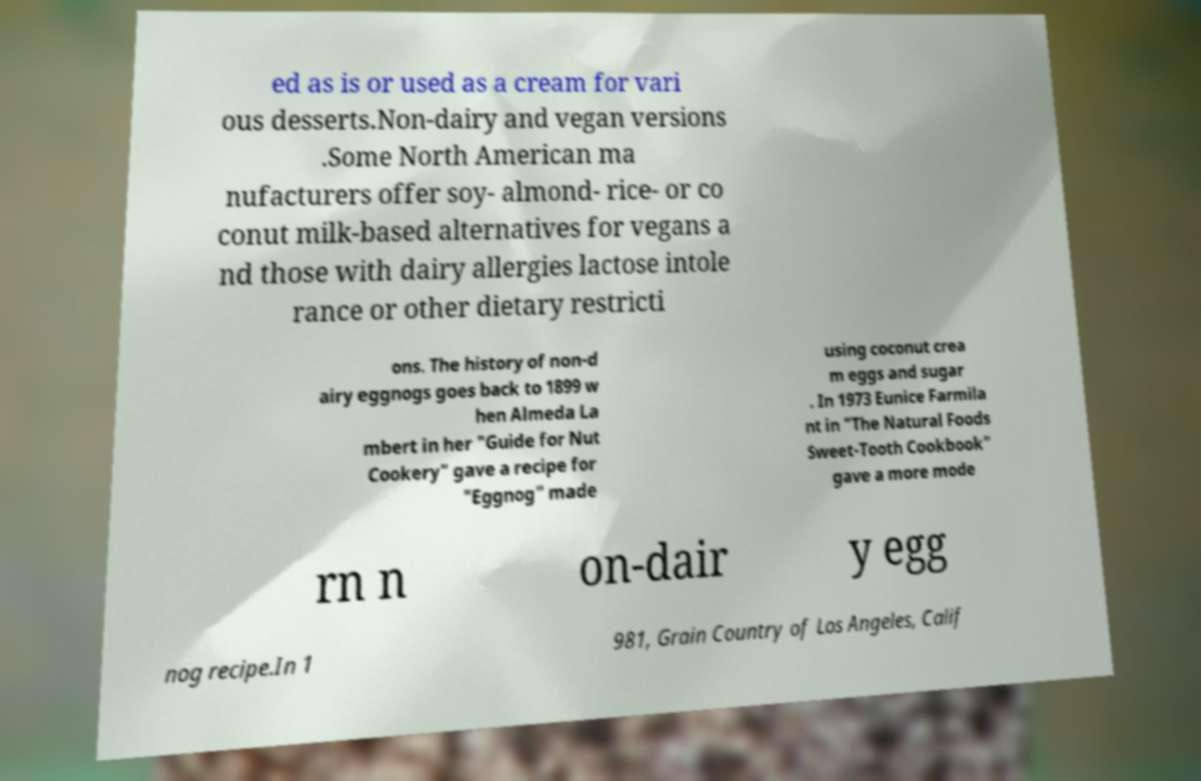Please identify and transcribe the text found in this image. ed as is or used as a cream for vari ous desserts.Non-dairy and vegan versions .Some North American ma nufacturers offer soy- almond- rice- or co conut milk-based alternatives for vegans a nd those with dairy allergies lactose intole rance or other dietary restricti ons. The history of non-d airy eggnogs goes back to 1899 w hen Almeda La mbert in her "Guide for Nut Cookery" gave a recipe for "Eggnog" made using coconut crea m eggs and sugar . In 1973 Eunice Farmila nt in "The Natural Foods Sweet-Tooth Cookbook" gave a more mode rn n on-dair y egg nog recipe.In 1 981, Grain Country of Los Angeles, Calif 